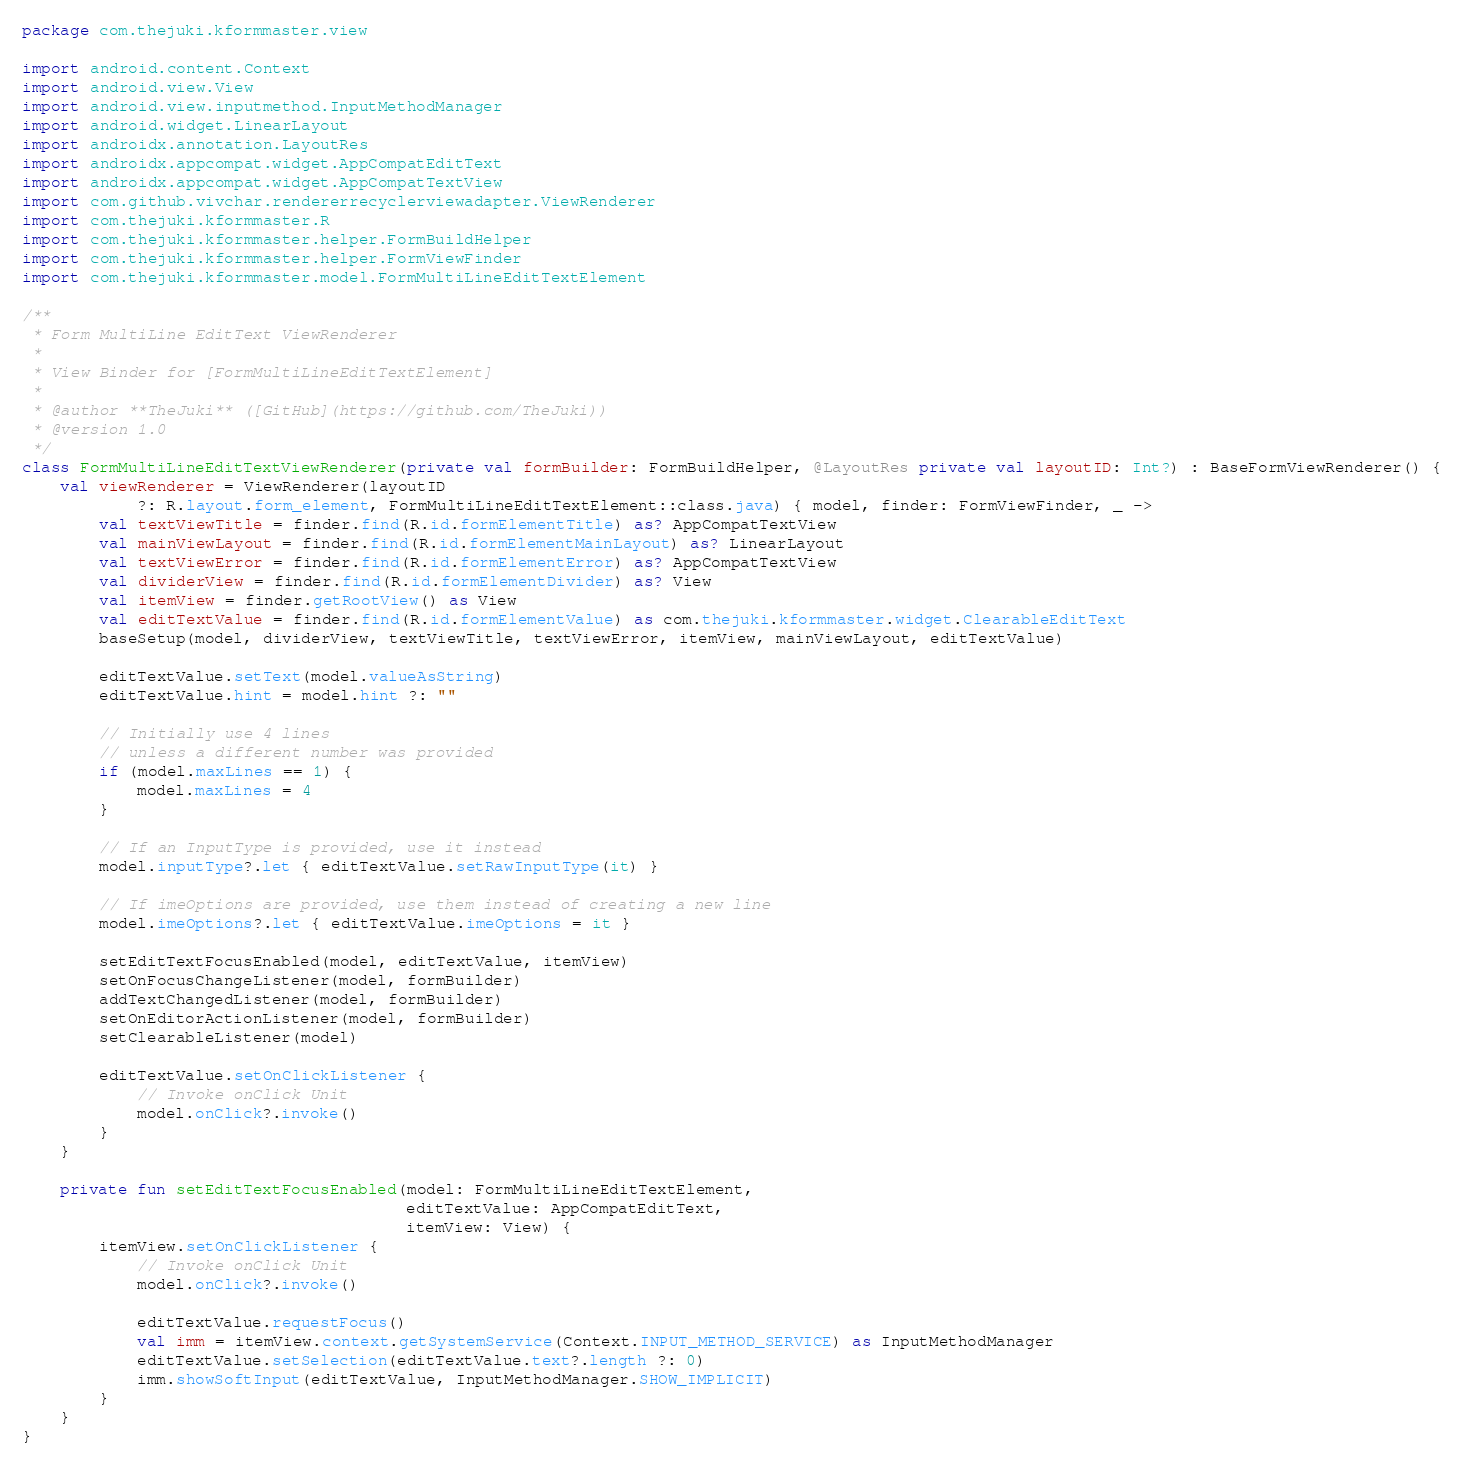Convert code to text. <code><loc_0><loc_0><loc_500><loc_500><_Kotlin_>package com.thejuki.kformmaster.view

import android.content.Context
import android.view.View
import android.view.inputmethod.InputMethodManager
import android.widget.LinearLayout
import androidx.annotation.LayoutRes
import androidx.appcompat.widget.AppCompatEditText
import androidx.appcompat.widget.AppCompatTextView
import com.github.vivchar.rendererrecyclerviewadapter.ViewRenderer
import com.thejuki.kformmaster.R
import com.thejuki.kformmaster.helper.FormBuildHelper
import com.thejuki.kformmaster.helper.FormViewFinder
import com.thejuki.kformmaster.model.FormMultiLineEditTextElement

/**
 * Form MultiLine EditText ViewRenderer
 *
 * View Binder for [FormMultiLineEditTextElement]
 *
 * @author **TheJuki** ([GitHub](https://github.com/TheJuki))
 * @version 1.0
 */
class FormMultiLineEditTextViewRenderer(private val formBuilder: FormBuildHelper, @LayoutRes private val layoutID: Int?) : BaseFormViewRenderer() {
    val viewRenderer = ViewRenderer(layoutID
            ?: R.layout.form_element, FormMultiLineEditTextElement::class.java) { model, finder: FormViewFinder, _ ->
        val textViewTitle = finder.find(R.id.formElementTitle) as? AppCompatTextView
        val mainViewLayout = finder.find(R.id.formElementMainLayout) as? LinearLayout
        val textViewError = finder.find(R.id.formElementError) as? AppCompatTextView
        val dividerView = finder.find(R.id.formElementDivider) as? View
        val itemView = finder.getRootView() as View
        val editTextValue = finder.find(R.id.formElementValue) as com.thejuki.kformmaster.widget.ClearableEditText
        baseSetup(model, dividerView, textViewTitle, textViewError, itemView, mainViewLayout, editTextValue)

        editTextValue.setText(model.valueAsString)
        editTextValue.hint = model.hint ?: ""

        // Initially use 4 lines
        // unless a different number was provided
        if (model.maxLines == 1) {
            model.maxLines = 4
        }

        // If an InputType is provided, use it instead
        model.inputType?.let { editTextValue.setRawInputType(it) }

        // If imeOptions are provided, use them instead of creating a new line
        model.imeOptions?.let { editTextValue.imeOptions = it }

        setEditTextFocusEnabled(model, editTextValue, itemView)
        setOnFocusChangeListener(model, formBuilder)
        addTextChangedListener(model, formBuilder)
        setOnEditorActionListener(model, formBuilder)
        setClearableListener(model)

        editTextValue.setOnClickListener {
            // Invoke onClick Unit
            model.onClick?.invoke()
        }
    }

    private fun setEditTextFocusEnabled(model: FormMultiLineEditTextElement,
                                        editTextValue: AppCompatEditText,
                                        itemView: View) {
        itemView.setOnClickListener {
            // Invoke onClick Unit
            model.onClick?.invoke()

            editTextValue.requestFocus()
            val imm = itemView.context.getSystemService(Context.INPUT_METHOD_SERVICE) as InputMethodManager
            editTextValue.setSelection(editTextValue.text?.length ?: 0)
            imm.showSoftInput(editTextValue, InputMethodManager.SHOW_IMPLICIT)
        }
    }
}
</code> 